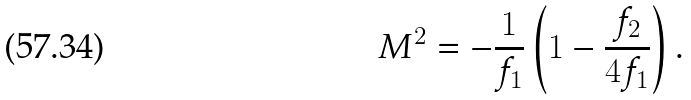Convert formula to latex. <formula><loc_0><loc_0><loc_500><loc_500>M ^ { 2 } = - \frac { 1 } { f _ { 1 } } \left ( 1 - \frac { f _ { 2 } } { 4 f _ { 1 } } \right ) .</formula> 